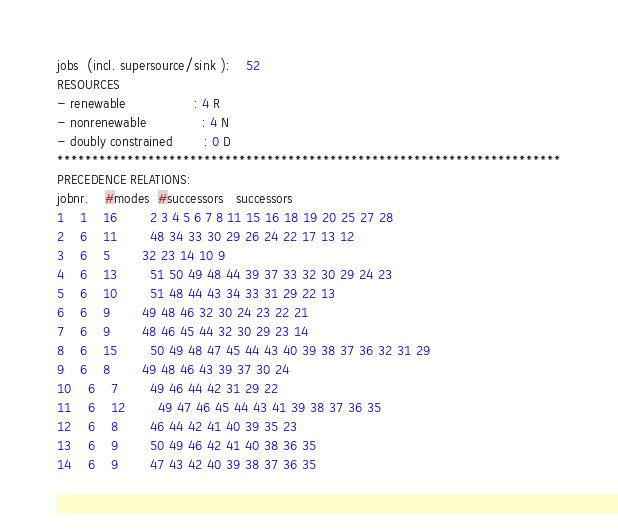<code> <loc_0><loc_0><loc_500><loc_500><_ObjectiveC_>jobs  (incl. supersource/sink ):	52
RESOURCES
- renewable                 : 4 R
- nonrenewable              : 4 N
- doubly constrained        : 0 D
************************************************************************
PRECEDENCE RELATIONS:
jobnr.    #modes  #successors   successors
1	1	16		2 3 4 5 6 7 8 11 15 16 18 19 20 25 27 28 
2	6	11		48 34 33 30 29 26 24 22 17 13 12 
3	6	5		32 23 14 10 9 
4	6	13		51 50 49 48 44 39 37 33 32 30 29 24 23 
5	6	10		51 48 44 43 34 33 31 29 22 13 
6	6	9		49 48 46 32 30 24 23 22 21 
7	6	9		48 46 45 44 32 30 29 23 14 
8	6	15		50 49 48 47 45 44 43 40 39 38 37 36 32 31 29 
9	6	8		49 48 46 43 39 37 30 24 
10	6	7		49 46 44 42 31 29 22 
11	6	12		49 47 46 45 44 43 41 39 38 37 36 35 
12	6	8		46 44 42 41 40 39 35 23 
13	6	9		50 49 46 42 41 40 38 36 35 
14	6	9		47 43 42 40 39 38 37 36 35 </code> 